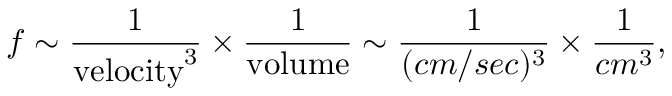<formula> <loc_0><loc_0><loc_500><loc_500>f \sim \frac { 1 } { v e l o c i t y ^ { 3 } } \times \frac { 1 } { v o l u m e } \sim \frac { 1 } { ( c m / s e c ) ^ { 3 } } \times \frac { 1 } { c m ^ { 3 } } ,</formula> 